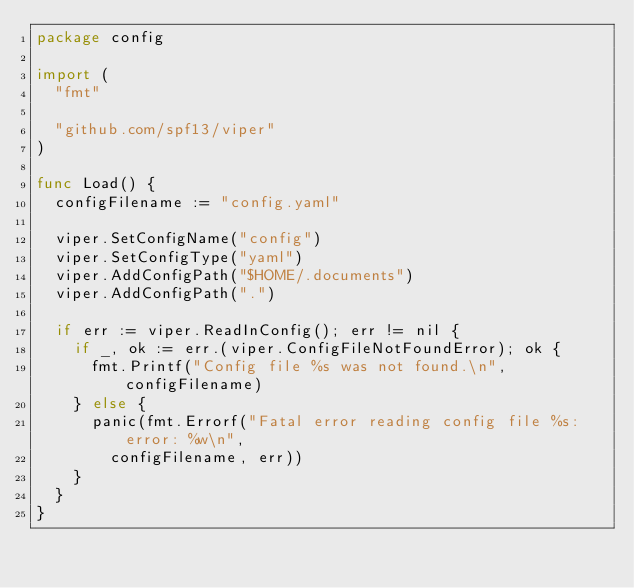Convert code to text. <code><loc_0><loc_0><loc_500><loc_500><_Go_>package config

import (
	"fmt"

	"github.com/spf13/viper"
)

func Load() {
	configFilename := "config.yaml"

	viper.SetConfigName("config")
	viper.SetConfigType("yaml")
	viper.AddConfigPath("$HOME/.documents")
	viper.AddConfigPath(".")

	if err := viper.ReadInConfig(); err != nil {
		if _, ok := err.(viper.ConfigFileNotFoundError); ok {
			fmt.Printf("Config file %s was not found.\n", configFilename)
		} else {
			panic(fmt.Errorf("Fatal error reading config file %s: error: %w\n",
				configFilename, err))
		}
	}
}
</code> 